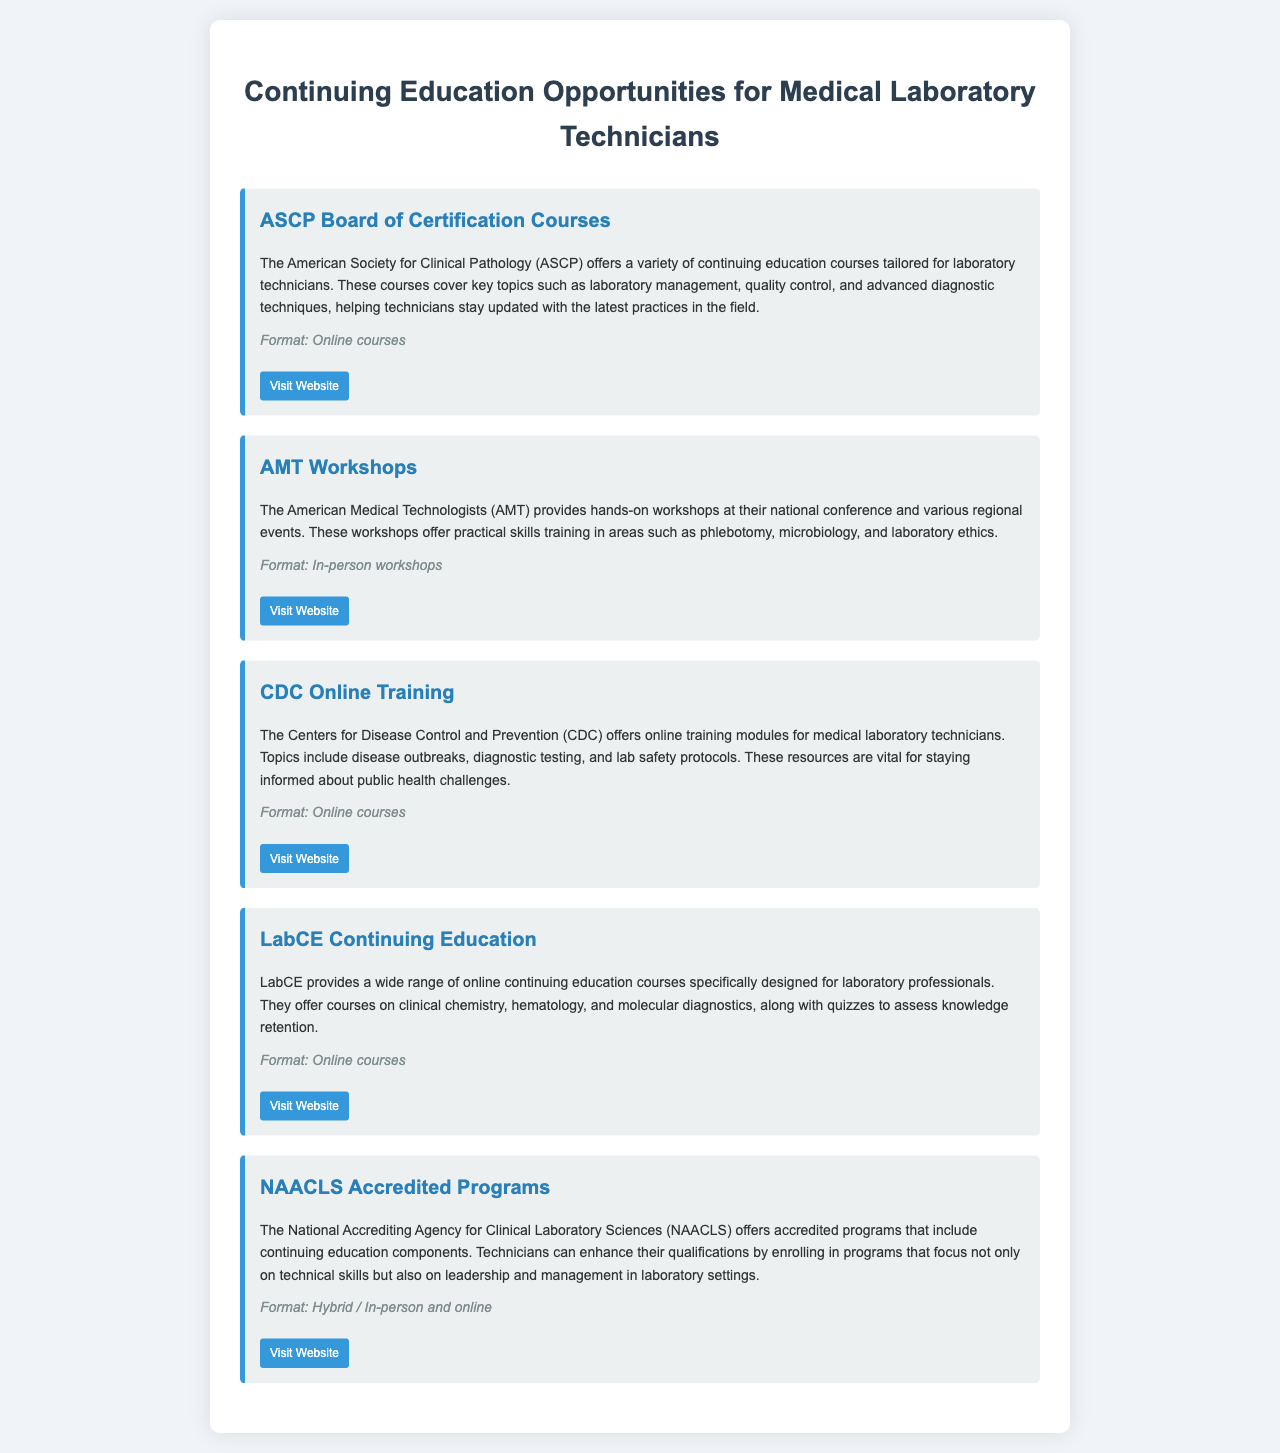What organization offers Board of Certification Courses? The document states that the American Society for Clinical Pathology (ASCP) offers Board of Certification Courses.
Answer: ASCP What format do AMT Workshops follow? The document specifies that AMT Workshops are conducted in-person.
Answer: In-person workshops Which online training does the CDC provide? The document mentions that the CDC offers online training modules for medical laboratory technicians.
Answer: Online training modules Name one subject offered by LabCE courses. The document lists courses on clinical chemistry, hematology, and molecular diagnostics.
Answer: Clinical chemistry What type of programs does NAACLS offer? The document indicates that NAACLS offers accredited programs that include continuing education components.
Answer: Accredited programs How many organizations are cited in the document? The document features five organizations providing continuing education opportunities.
Answer: Five What topic is covered in CDC's Online Training? The document highlights disease outbreaks, diagnostic testing, and lab safety protocols as topics covered.
Answer: Disease outbreaks What is a unique feature of LabCE courses? The document states that LabCE offers quizzes to assess knowledge retention in their courses.
Answer: Quizzes What is the primary focus of NAACLS accredited programs? The document explains that these programs focus on technical skills as well as leadership and management in laboratory settings.
Answer: Technical skills and leadership 